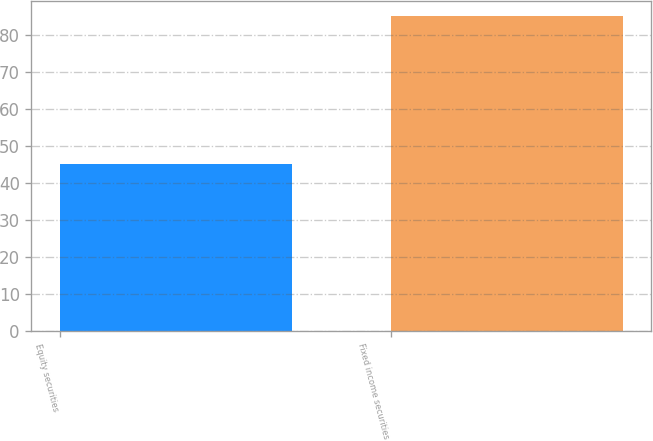<chart> <loc_0><loc_0><loc_500><loc_500><bar_chart><fcel>Equity securities<fcel>Fixed income securities<nl><fcel>45<fcel>85<nl></chart> 